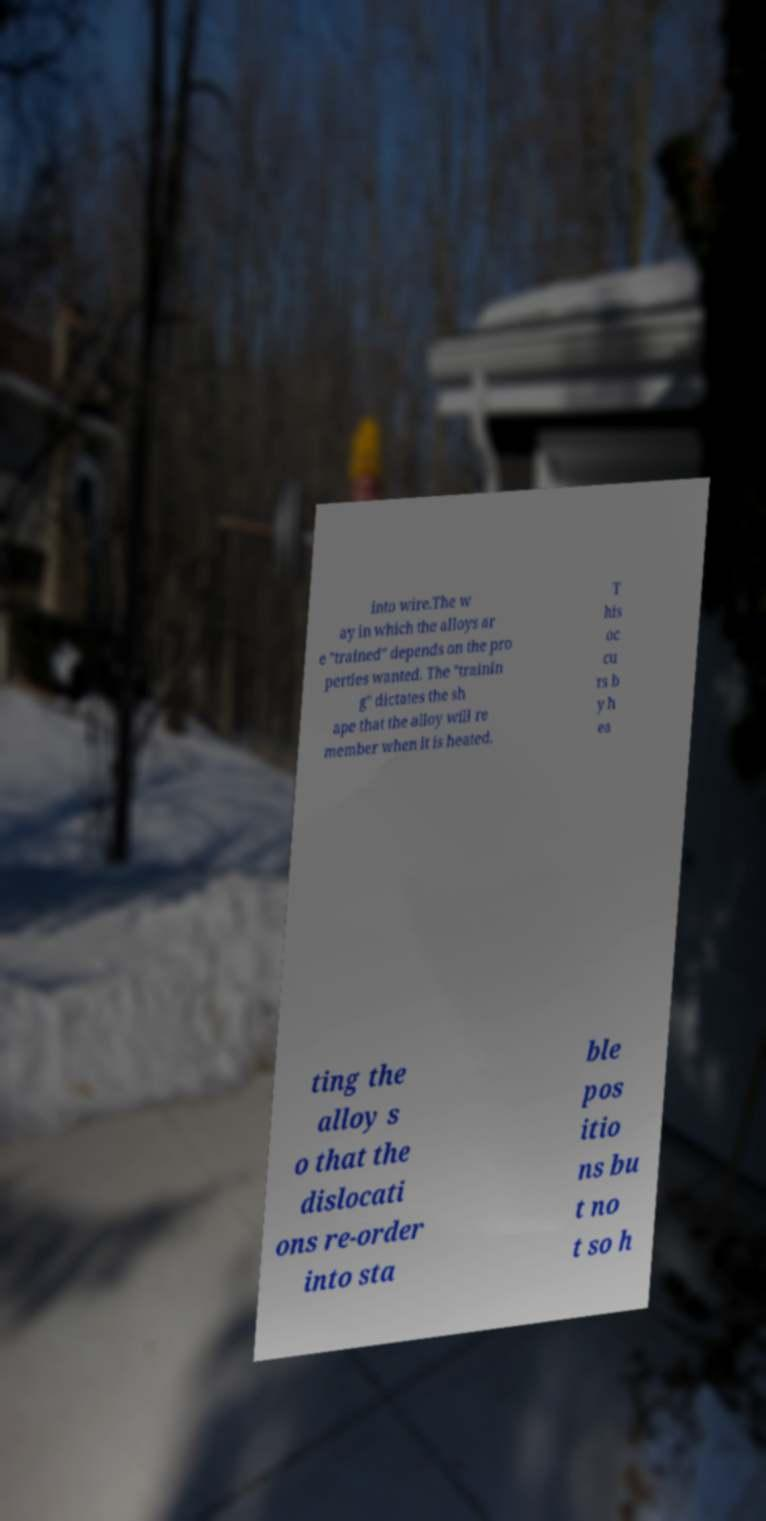What messages or text are displayed in this image? I need them in a readable, typed format. into wire.The w ay in which the alloys ar e "trained" depends on the pro perties wanted. The "trainin g" dictates the sh ape that the alloy will re member when it is heated. T his oc cu rs b y h ea ting the alloy s o that the dislocati ons re-order into sta ble pos itio ns bu t no t so h 